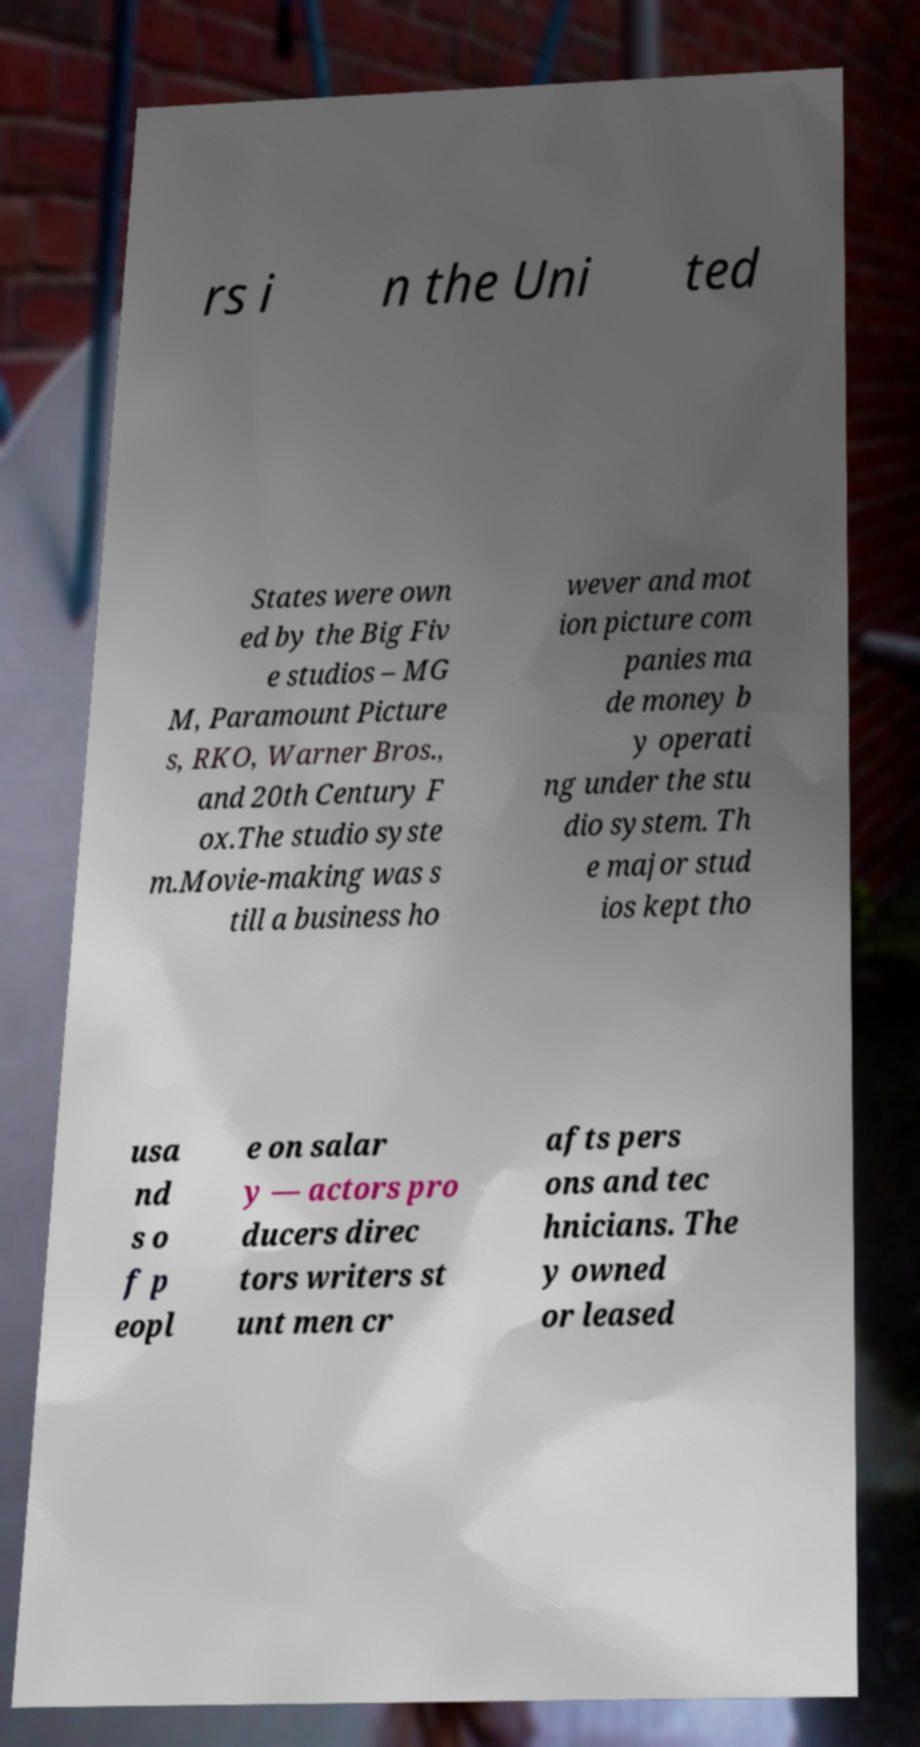Can you read and provide the text displayed in the image?This photo seems to have some interesting text. Can you extract and type it out for me? rs i n the Uni ted States were own ed by the Big Fiv e studios – MG M, Paramount Picture s, RKO, Warner Bros., and 20th Century F ox.The studio syste m.Movie-making was s till a business ho wever and mot ion picture com panies ma de money b y operati ng under the stu dio system. Th e major stud ios kept tho usa nd s o f p eopl e on salar y — actors pro ducers direc tors writers st unt men cr afts pers ons and tec hnicians. The y owned or leased 